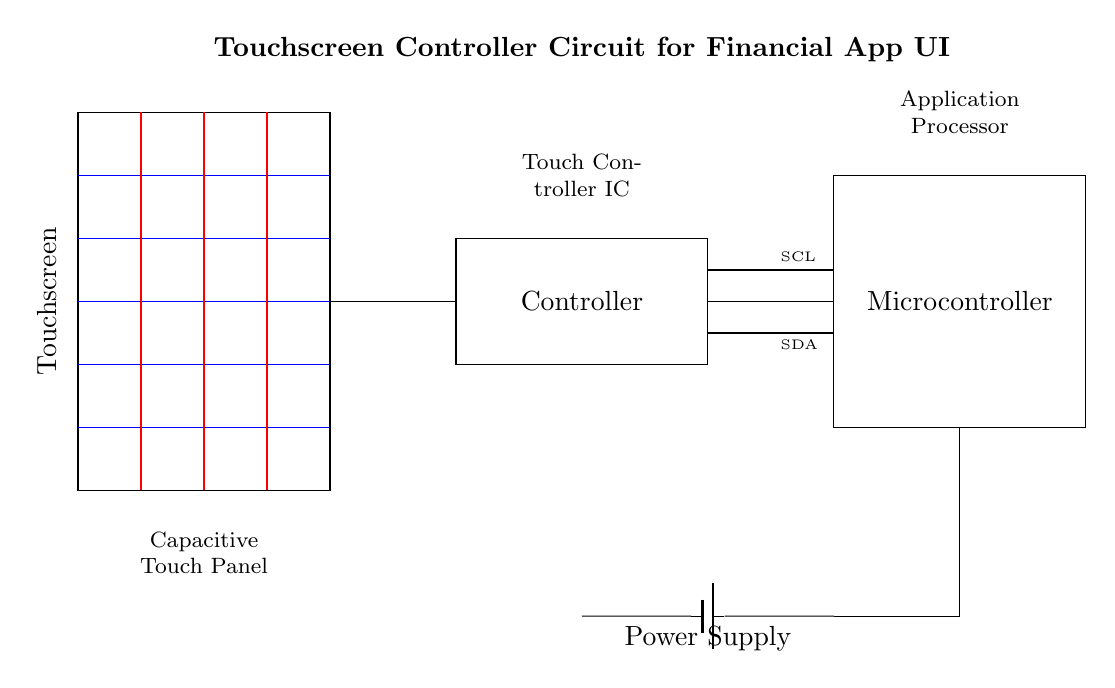What component represents the user interface? The user interface is represented by the rectangle labeled "Touchscreen" which indicates the part of the circuit where user interaction occurs.
Answer: Touchscreen What type of connection is used between the controller and the microcontroller? The connection between the controller and the microcontroller is indicated by a straight line, suggesting a standard wire connection for data transmission.
Answer: Wire What does SCL stand for in this circuit? SCL stands for Serial Clock Line, which is part of the I2C bus used for communication between components in the circuit.
Answer: Serial Clock Line How many capacitive sensing lines are present? There are five capacitive sensing lines shown in the circuit diagram, indicated by the blue lines extending from the touchscreen.
Answer: Five What is the purpose of the battery in this circuit? The battery provides the necessary power supply for the entire circuit, ensuring that all components function properly by supplying voltage.
Answer: Power supply Which component handles data processing? The component responsible for data processing is the "Microcontroller," as labeled in the circuit diagram where it interfaces with both the touchscreen and the controller.
Answer: Microcontroller What is the voltage of the power supply indicated in the circuit? The specific voltage is not directly stated in the diagram but is typically a standard value like 3.3V or 5V for such devices; however, it is drawn symbolically.
Answer: Not specified 